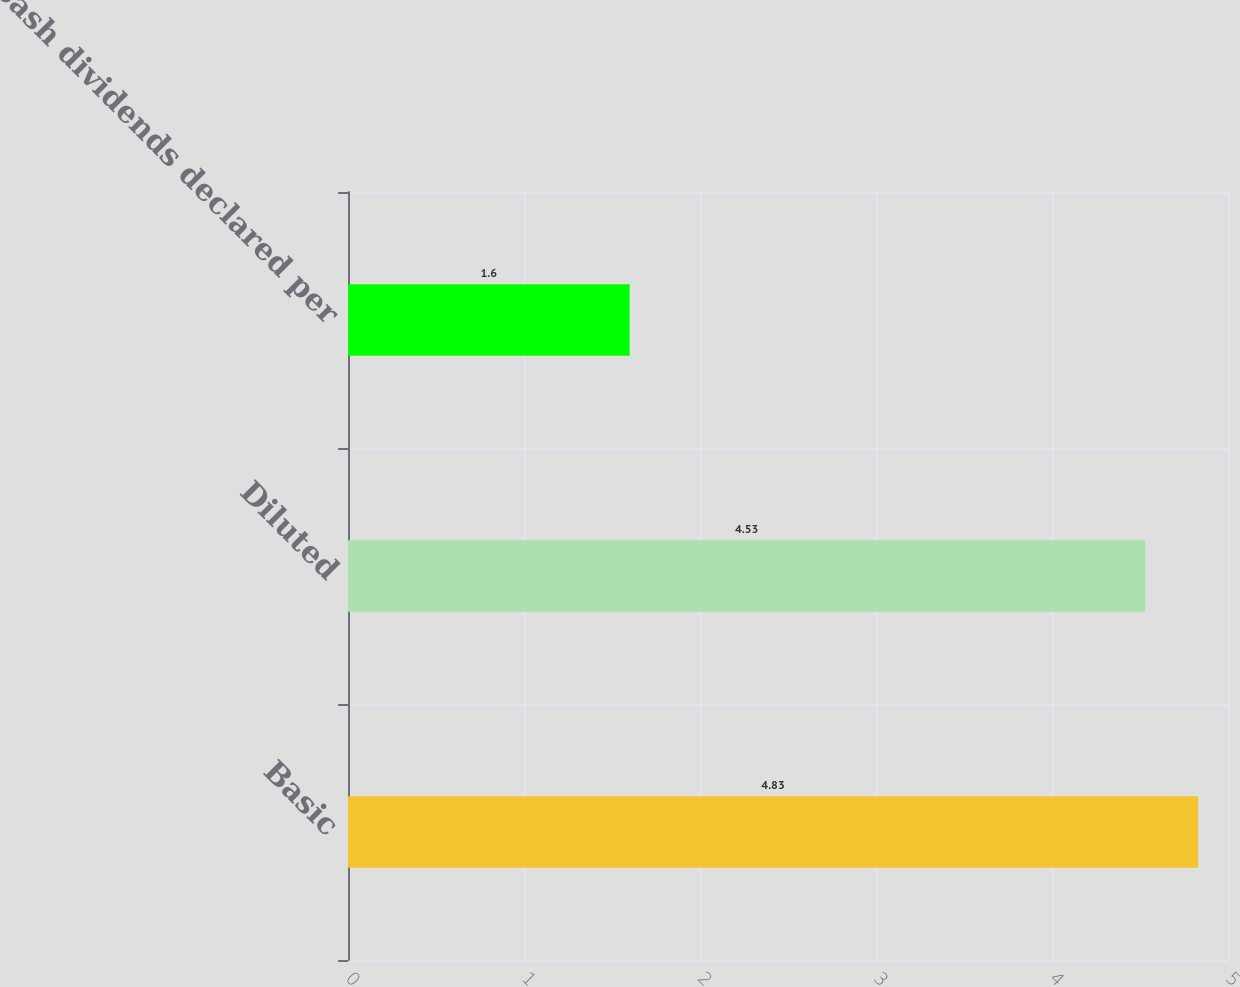Convert chart to OTSL. <chart><loc_0><loc_0><loc_500><loc_500><bar_chart><fcel>Basic<fcel>Diluted<fcel>Cash dividends declared per<nl><fcel>4.83<fcel>4.53<fcel>1.6<nl></chart> 